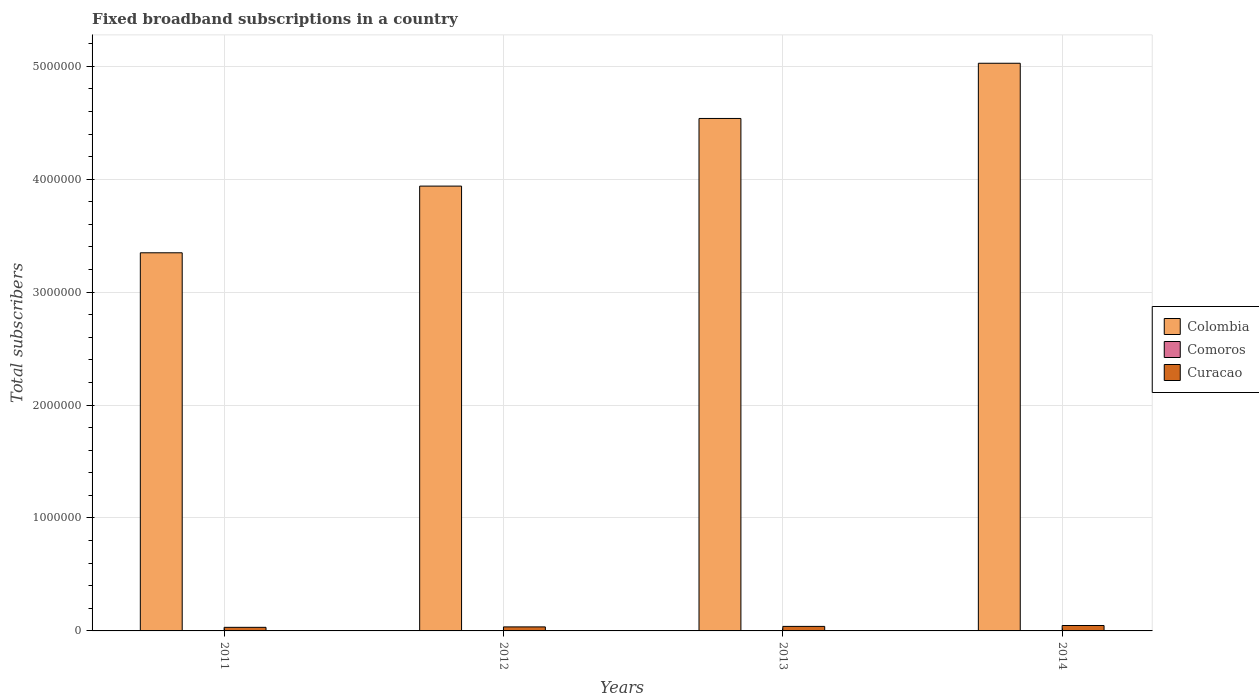How many groups of bars are there?
Your answer should be very brief. 4. Are the number of bars per tick equal to the number of legend labels?
Ensure brevity in your answer.  Yes. What is the label of the 4th group of bars from the left?
Provide a short and direct response. 2014. In how many cases, is the number of bars for a given year not equal to the number of legend labels?
Your answer should be very brief. 0. What is the number of broadband subscriptions in Comoros in 2012?
Give a very brief answer. 1233. Across all years, what is the maximum number of broadband subscriptions in Colombia?
Keep it short and to the point. 5.03e+06. Across all years, what is the minimum number of broadband subscriptions in Comoros?
Keep it short and to the point. 400. In which year was the number of broadband subscriptions in Comoros maximum?
Provide a succinct answer. 2014. In which year was the number of broadband subscriptions in Curacao minimum?
Provide a short and direct response. 2011. What is the total number of broadband subscriptions in Comoros in the graph?
Make the answer very short. 4516. What is the difference between the number of broadband subscriptions in Curacao in 2011 and that in 2012?
Provide a succinct answer. -3782. What is the difference between the number of broadband subscriptions in Colombia in 2014 and the number of broadband subscriptions in Comoros in 2013?
Ensure brevity in your answer.  5.03e+06. What is the average number of broadband subscriptions in Curacao per year?
Your answer should be very brief. 3.88e+04. In the year 2013, what is the difference between the number of broadband subscriptions in Colombia and number of broadband subscriptions in Comoros?
Offer a very short reply. 4.54e+06. In how many years, is the number of broadband subscriptions in Colombia greater than 4400000?
Your response must be concise. 2. What is the ratio of the number of broadband subscriptions in Curacao in 2011 to that in 2014?
Offer a terse response. 0.66. Is the number of broadband subscriptions in Curacao in 2012 less than that in 2013?
Give a very brief answer. Yes. What is the difference between the highest and the second highest number of broadband subscriptions in Curacao?
Your answer should be very brief. 8000. What is the difference between the highest and the lowest number of broadband subscriptions in Colombia?
Your answer should be very brief. 1.68e+06. Is the sum of the number of broadband subscriptions in Curacao in 2011 and 2012 greater than the maximum number of broadband subscriptions in Colombia across all years?
Offer a very short reply. No. What does the 3rd bar from the right in 2013 represents?
Give a very brief answer. Colombia. Is it the case that in every year, the sum of the number of broadband subscriptions in Curacao and number of broadband subscriptions in Comoros is greater than the number of broadband subscriptions in Colombia?
Keep it short and to the point. No. What is the difference between two consecutive major ticks on the Y-axis?
Keep it short and to the point. 1.00e+06. Are the values on the major ticks of Y-axis written in scientific E-notation?
Your answer should be very brief. No. Does the graph contain any zero values?
Ensure brevity in your answer.  No. Where does the legend appear in the graph?
Make the answer very short. Center right. How many legend labels are there?
Offer a very short reply. 3. How are the legend labels stacked?
Your response must be concise. Vertical. What is the title of the graph?
Provide a succinct answer. Fixed broadband subscriptions in a country. Does "France" appear as one of the legend labels in the graph?
Your answer should be very brief. No. What is the label or title of the X-axis?
Provide a short and direct response. Years. What is the label or title of the Y-axis?
Your answer should be compact. Total subscribers. What is the Total subscribers in Colombia in 2011?
Provide a succinct answer. 3.35e+06. What is the Total subscribers of Curacao in 2011?
Give a very brief answer. 3.18e+04. What is the Total subscribers of Colombia in 2012?
Offer a terse response. 3.94e+06. What is the Total subscribers in Comoros in 2012?
Your response must be concise. 1233. What is the Total subscribers of Curacao in 2012?
Keep it short and to the point. 3.56e+04. What is the Total subscribers of Colombia in 2013?
Your answer should be very brief. 4.54e+06. What is the Total subscribers in Comoros in 2013?
Your answer should be very brief. 1300. What is the Total subscribers of Curacao in 2013?
Offer a very short reply. 4.00e+04. What is the Total subscribers in Colombia in 2014?
Provide a succinct answer. 5.03e+06. What is the Total subscribers of Comoros in 2014?
Your answer should be compact. 1583. What is the Total subscribers of Curacao in 2014?
Keep it short and to the point. 4.80e+04. Across all years, what is the maximum Total subscribers of Colombia?
Offer a terse response. 5.03e+06. Across all years, what is the maximum Total subscribers in Comoros?
Your response must be concise. 1583. Across all years, what is the maximum Total subscribers of Curacao?
Offer a very short reply. 4.80e+04. Across all years, what is the minimum Total subscribers in Colombia?
Your answer should be very brief. 3.35e+06. Across all years, what is the minimum Total subscribers in Comoros?
Your response must be concise. 400. Across all years, what is the minimum Total subscribers of Curacao?
Offer a very short reply. 3.18e+04. What is the total Total subscribers of Colombia in the graph?
Provide a short and direct response. 1.69e+07. What is the total Total subscribers of Comoros in the graph?
Ensure brevity in your answer.  4516. What is the total Total subscribers in Curacao in the graph?
Your response must be concise. 1.55e+05. What is the difference between the Total subscribers in Colombia in 2011 and that in 2012?
Your answer should be very brief. -5.91e+05. What is the difference between the Total subscribers of Comoros in 2011 and that in 2012?
Your response must be concise. -833. What is the difference between the Total subscribers in Curacao in 2011 and that in 2012?
Offer a terse response. -3782. What is the difference between the Total subscribers of Colombia in 2011 and that in 2013?
Give a very brief answer. -1.19e+06. What is the difference between the Total subscribers of Comoros in 2011 and that in 2013?
Offer a very short reply. -900. What is the difference between the Total subscribers of Curacao in 2011 and that in 2013?
Your answer should be very brief. -8200. What is the difference between the Total subscribers in Colombia in 2011 and that in 2014?
Make the answer very short. -1.68e+06. What is the difference between the Total subscribers of Comoros in 2011 and that in 2014?
Offer a very short reply. -1183. What is the difference between the Total subscribers of Curacao in 2011 and that in 2014?
Make the answer very short. -1.62e+04. What is the difference between the Total subscribers in Colombia in 2012 and that in 2013?
Give a very brief answer. -5.99e+05. What is the difference between the Total subscribers of Comoros in 2012 and that in 2013?
Make the answer very short. -67. What is the difference between the Total subscribers of Curacao in 2012 and that in 2013?
Give a very brief answer. -4418. What is the difference between the Total subscribers of Colombia in 2012 and that in 2014?
Your answer should be very brief. -1.09e+06. What is the difference between the Total subscribers of Comoros in 2012 and that in 2014?
Offer a very short reply. -350. What is the difference between the Total subscribers in Curacao in 2012 and that in 2014?
Your response must be concise. -1.24e+04. What is the difference between the Total subscribers of Colombia in 2013 and that in 2014?
Your response must be concise. -4.89e+05. What is the difference between the Total subscribers in Comoros in 2013 and that in 2014?
Your answer should be compact. -283. What is the difference between the Total subscribers of Curacao in 2013 and that in 2014?
Offer a very short reply. -8000. What is the difference between the Total subscribers of Colombia in 2011 and the Total subscribers of Comoros in 2012?
Your response must be concise. 3.35e+06. What is the difference between the Total subscribers in Colombia in 2011 and the Total subscribers in Curacao in 2012?
Your answer should be very brief. 3.31e+06. What is the difference between the Total subscribers of Comoros in 2011 and the Total subscribers of Curacao in 2012?
Make the answer very short. -3.52e+04. What is the difference between the Total subscribers of Colombia in 2011 and the Total subscribers of Comoros in 2013?
Keep it short and to the point. 3.35e+06. What is the difference between the Total subscribers of Colombia in 2011 and the Total subscribers of Curacao in 2013?
Offer a very short reply. 3.31e+06. What is the difference between the Total subscribers in Comoros in 2011 and the Total subscribers in Curacao in 2013?
Offer a terse response. -3.96e+04. What is the difference between the Total subscribers in Colombia in 2011 and the Total subscribers in Comoros in 2014?
Keep it short and to the point. 3.35e+06. What is the difference between the Total subscribers in Colombia in 2011 and the Total subscribers in Curacao in 2014?
Provide a short and direct response. 3.30e+06. What is the difference between the Total subscribers in Comoros in 2011 and the Total subscribers in Curacao in 2014?
Give a very brief answer. -4.76e+04. What is the difference between the Total subscribers in Colombia in 2012 and the Total subscribers in Comoros in 2013?
Your answer should be very brief. 3.94e+06. What is the difference between the Total subscribers in Colombia in 2012 and the Total subscribers in Curacao in 2013?
Make the answer very short. 3.90e+06. What is the difference between the Total subscribers of Comoros in 2012 and the Total subscribers of Curacao in 2013?
Your answer should be very brief. -3.88e+04. What is the difference between the Total subscribers in Colombia in 2012 and the Total subscribers in Comoros in 2014?
Your answer should be compact. 3.94e+06. What is the difference between the Total subscribers in Colombia in 2012 and the Total subscribers in Curacao in 2014?
Offer a very short reply. 3.89e+06. What is the difference between the Total subscribers in Comoros in 2012 and the Total subscribers in Curacao in 2014?
Offer a terse response. -4.68e+04. What is the difference between the Total subscribers in Colombia in 2013 and the Total subscribers in Comoros in 2014?
Give a very brief answer. 4.54e+06. What is the difference between the Total subscribers of Colombia in 2013 and the Total subscribers of Curacao in 2014?
Keep it short and to the point. 4.49e+06. What is the difference between the Total subscribers of Comoros in 2013 and the Total subscribers of Curacao in 2014?
Offer a very short reply. -4.67e+04. What is the average Total subscribers in Colombia per year?
Keep it short and to the point. 4.21e+06. What is the average Total subscribers of Comoros per year?
Provide a succinct answer. 1129. What is the average Total subscribers in Curacao per year?
Offer a very short reply. 3.88e+04. In the year 2011, what is the difference between the Total subscribers of Colombia and Total subscribers of Comoros?
Provide a succinct answer. 3.35e+06. In the year 2011, what is the difference between the Total subscribers in Colombia and Total subscribers in Curacao?
Make the answer very short. 3.32e+06. In the year 2011, what is the difference between the Total subscribers in Comoros and Total subscribers in Curacao?
Your answer should be compact. -3.14e+04. In the year 2012, what is the difference between the Total subscribers of Colombia and Total subscribers of Comoros?
Your response must be concise. 3.94e+06. In the year 2012, what is the difference between the Total subscribers in Colombia and Total subscribers in Curacao?
Provide a succinct answer. 3.90e+06. In the year 2012, what is the difference between the Total subscribers of Comoros and Total subscribers of Curacao?
Ensure brevity in your answer.  -3.43e+04. In the year 2013, what is the difference between the Total subscribers in Colombia and Total subscribers in Comoros?
Keep it short and to the point. 4.54e+06. In the year 2013, what is the difference between the Total subscribers of Colombia and Total subscribers of Curacao?
Provide a succinct answer. 4.50e+06. In the year 2013, what is the difference between the Total subscribers in Comoros and Total subscribers in Curacao?
Provide a succinct answer. -3.87e+04. In the year 2014, what is the difference between the Total subscribers in Colombia and Total subscribers in Comoros?
Ensure brevity in your answer.  5.02e+06. In the year 2014, what is the difference between the Total subscribers of Colombia and Total subscribers of Curacao?
Offer a very short reply. 4.98e+06. In the year 2014, what is the difference between the Total subscribers of Comoros and Total subscribers of Curacao?
Your answer should be compact. -4.64e+04. What is the ratio of the Total subscribers of Colombia in 2011 to that in 2012?
Ensure brevity in your answer.  0.85. What is the ratio of the Total subscribers in Comoros in 2011 to that in 2012?
Ensure brevity in your answer.  0.32. What is the ratio of the Total subscribers in Curacao in 2011 to that in 2012?
Keep it short and to the point. 0.89. What is the ratio of the Total subscribers in Colombia in 2011 to that in 2013?
Offer a terse response. 0.74. What is the ratio of the Total subscribers in Comoros in 2011 to that in 2013?
Your response must be concise. 0.31. What is the ratio of the Total subscribers in Curacao in 2011 to that in 2013?
Your answer should be compact. 0.8. What is the ratio of the Total subscribers in Colombia in 2011 to that in 2014?
Your response must be concise. 0.67. What is the ratio of the Total subscribers in Comoros in 2011 to that in 2014?
Make the answer very short. 0.25. What is the ratio of the Total subscribers of Curacao in 2011 to that in 2014?
Ensure brevity in your answer.  0.66. What is the ratio of the Total subscribers in Colombia in 2012 to that in 2013?
Offer a terse response. 0.87. What is the ratio of the Total subscribers in Comoros in 2012 to that in 2013?
Make the answer very short. 0.95. What is the ratio of the Total subscribers in Curacao in 2012 to that in 2013?
Provide a succinct answer. 0.89. What is the ratio of the Total subscribers of Colombia in 2012 to that in 2014?
Offer a terse response. 0.78. What is the ratio of the Total subscribers in Comoros in 2012 to that in 2014?
Make the answer very short. 0.78. What is the ratio of the Total subscribers in Curacao in 2012 to that in 2014?
Your answer should be very brief. 0.74. What is the ratio of the Total subscribers in Colombia in 2013 to that in 2014?
Make the answer very short. 0.9. What is the ratio of the Total subscribers of Comoros in 2013 to that in 2014?
Provide a succinct answer. 0.82. What is the difference between the highest and the second highest Total subscribers in Colombia?
Ensure brevity in your answer.  4.89e+05. What is the difference between the highest and the second highest Total subscribers in Comoros?
Ensure brevity in your answer.  283. What is the difference between the highest and the second highest Total subscribers of Curacao?
Provide a short and direct response. 8000. What is the difference between the highest and the lowest Total subscribers in Colombia?
Ensure brevity in your answer.  1.68e+06. What is the difference between the highest and the lowest Total subscribers in Comoros?
Your response must be concise. 1183. What is the difference between the highest and the lowest Total subscribers of Curacao?
Your answer should be very brief. 1.62e+04. 